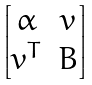<formula> <loc_0><loc_0><loc_500><loc_500>\begin{bmatrix} \alpha & v \\ v ^ { T } & B \end{bmatrix}</formula> 